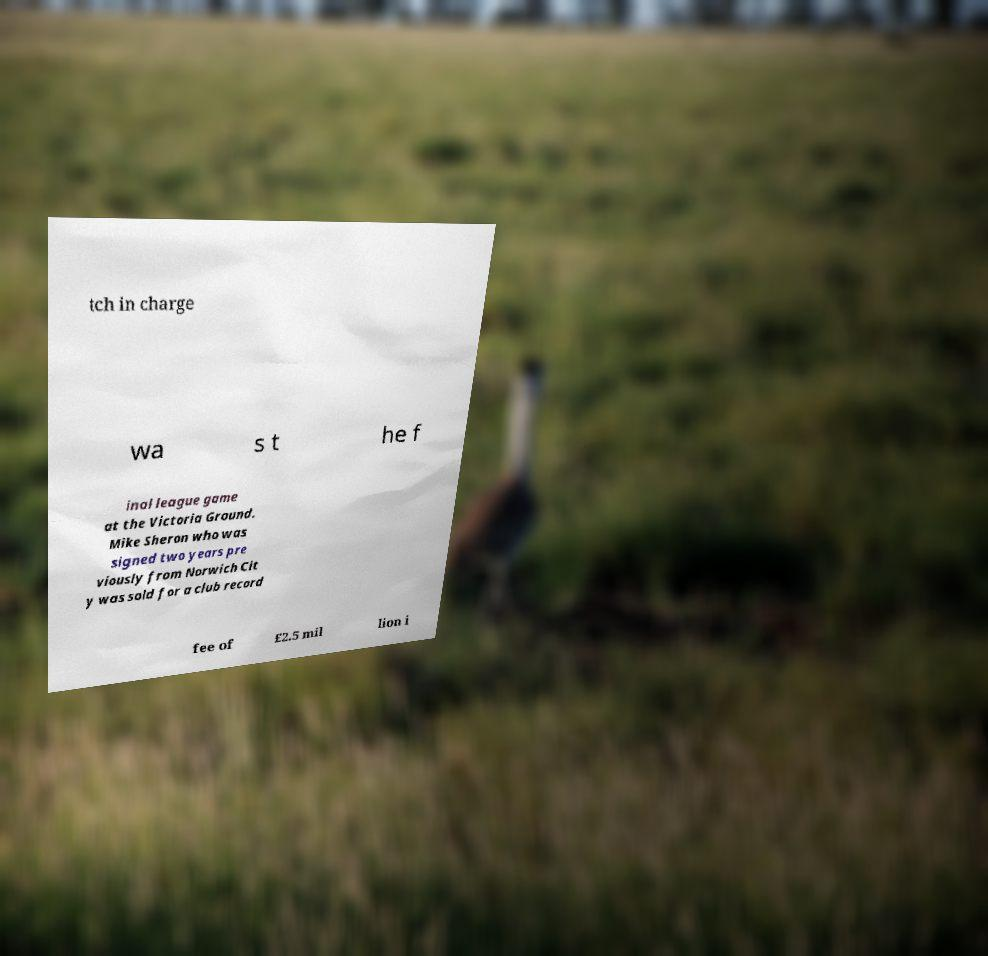Could you extract and type out the text from this image? tch in charge wa s t he f inal league game at the Victoria Ground. Mike Sheron who was signed two years pre viously from Norwich Cit y was sold for a club record fee of £2.5 mil lion i 